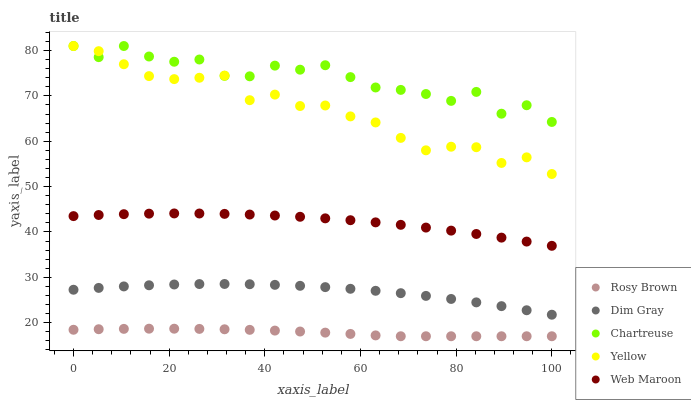Does Rosy Brown have the minimum area under the curve?
Answer yes or no. Yes. Does Chartreuse have the maximum area under the curve?
Answer yes or no. Yes. Does Web Maroon have the minimum area under the curve?
Answer yes or no. No. Does Web Maroon have the maximum area under the curve?
Answer yes or no. No. Is Rosy Brown the smoothest?
Answer yes or no. Yes. Is Chartreuse the roughest?
Answer yes or no. Yes. Is Web Maroon the smoothest?
Answer yes or no. No. Is Web Maroon the roughest?
Answer yes or no. No. Does Rosy Brown have the lowest value?
Answer yes or no. Yes. Does Web Maroon have the lowest value?
Answer yes or no. No. Does Yellow have the highest value?
Answer yes or no. Yes. Does Web Maroon have the highest value?
Answer yes or no. No. Is Rosy Brown less than Yellow?
Answer yes or no. Yes. Is Yellow greater than Rosy Brown?
Answer yes or no. Yes. Does Chartreuse intersect Yellow?
Answer yes or no. Yes. Is Chartreuse less than Yellow?
Answer yes or no. No. Is Chartreuse greater than Yellow?
Answer yes or no. No. Does Rosy Brown intersect Yellow?
Answer yes or no. No. 